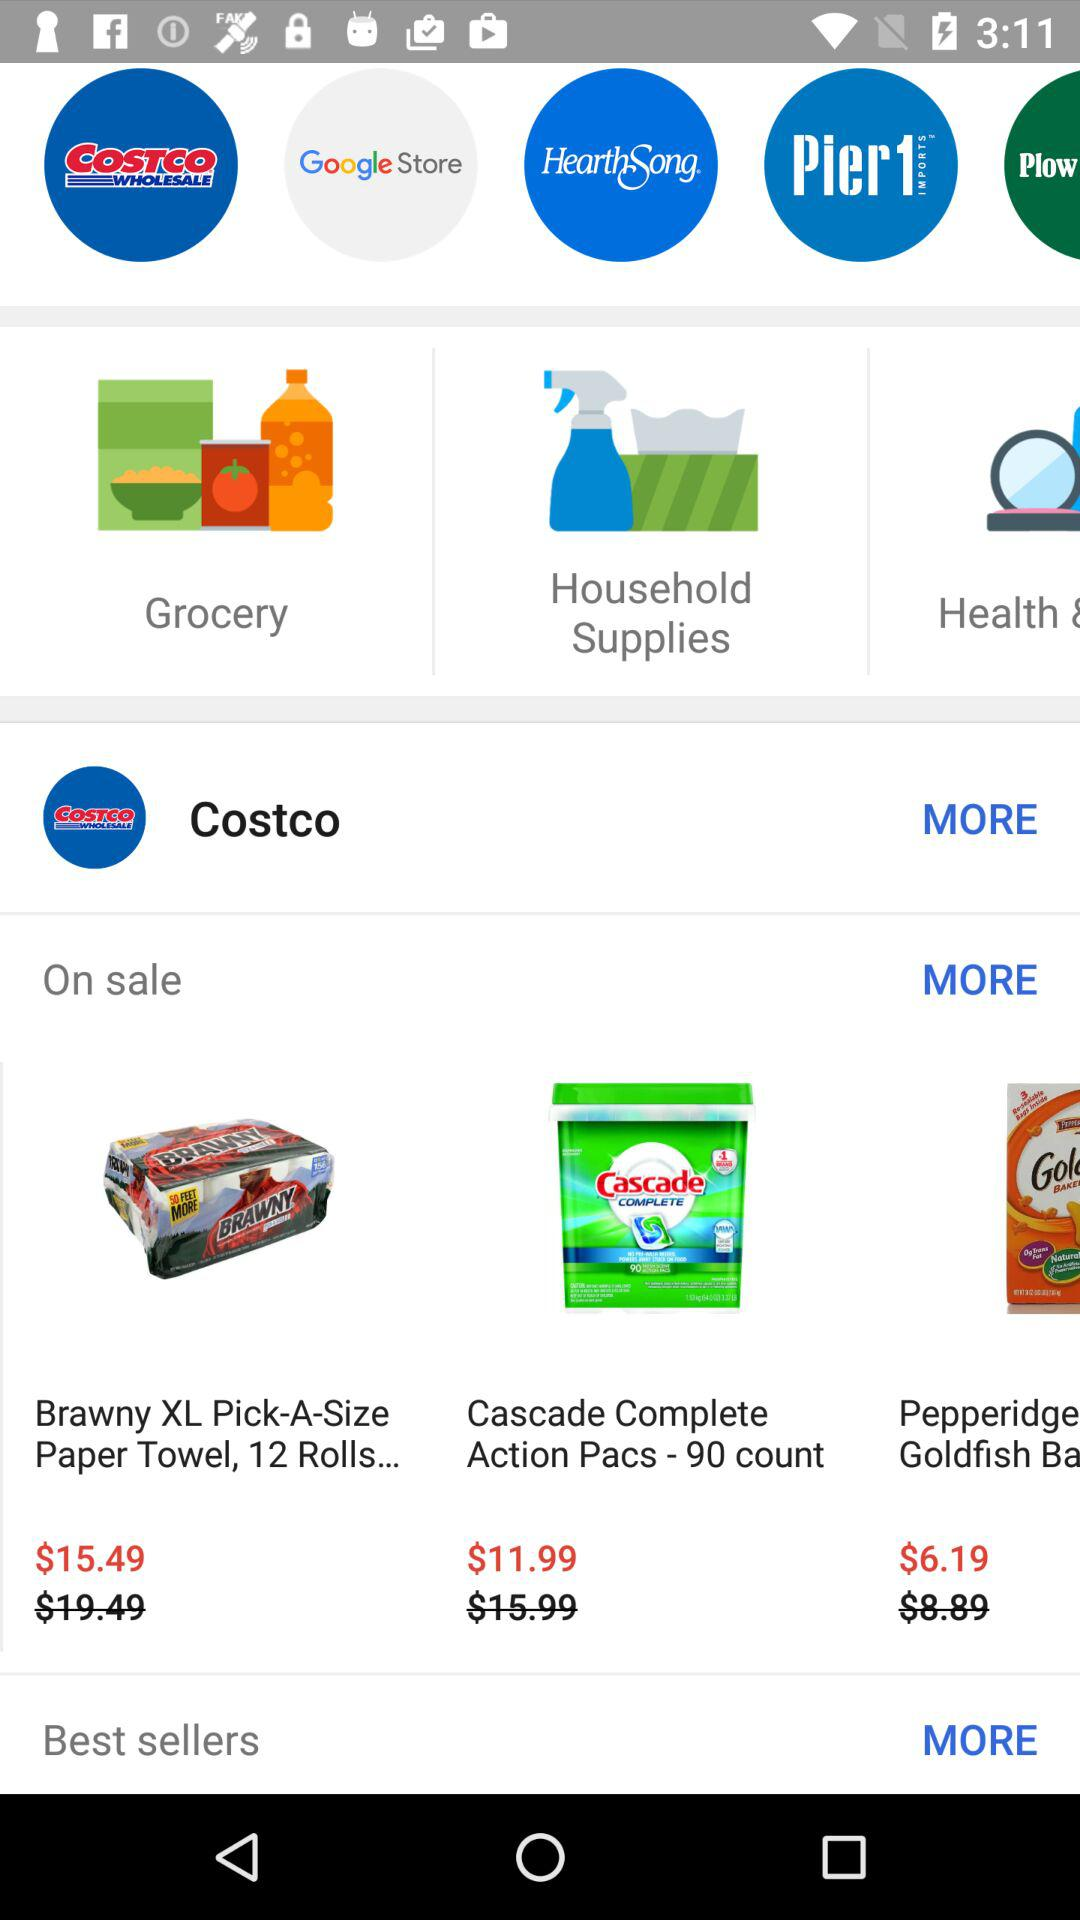What is the amount you should pay to buy a "Pepperidge Goldfish"? The amount that should be paid is $6.19. 